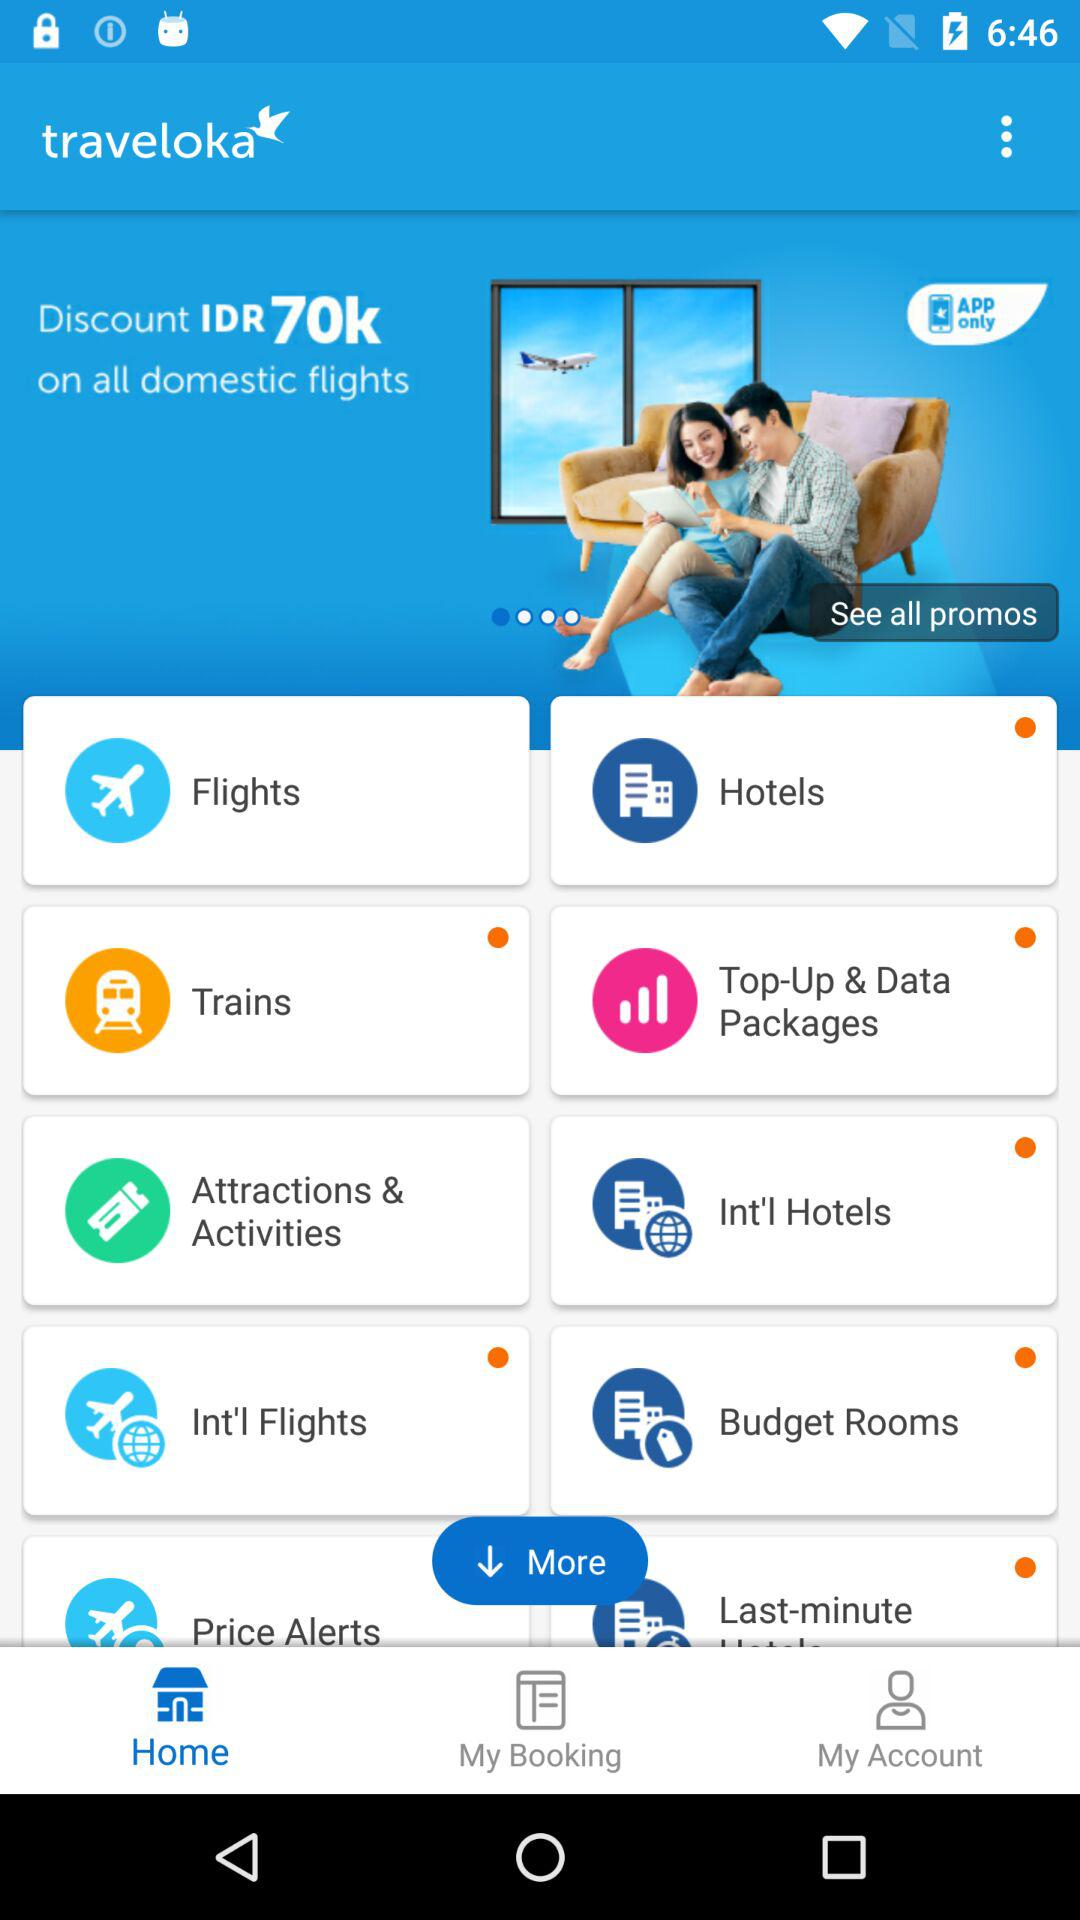What is the name of the application? The application name is "traveloka". 